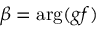Convert formula to latex. <formula><loc_0><loc_0><loc_500><loc_500>\beta = \arg ( g f )</formula> 